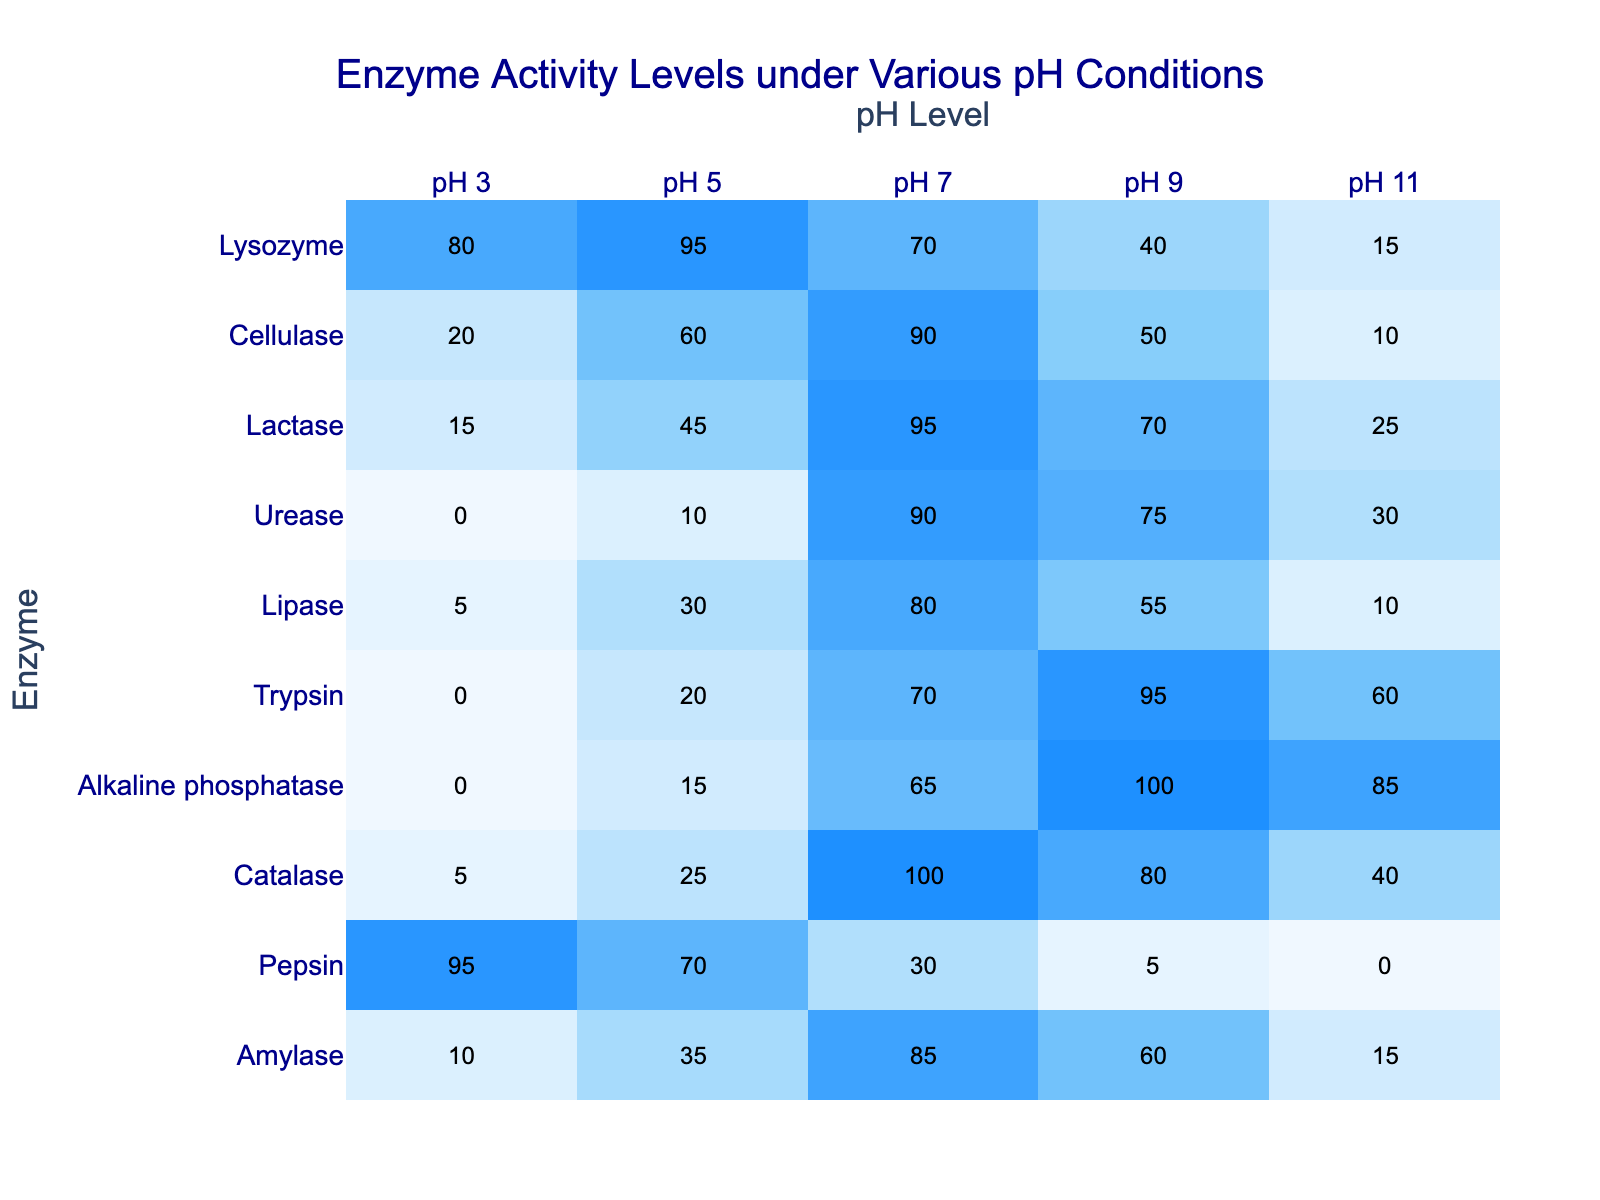What is the enzyme with the highest activity level at pH 7? The activity levels for pH 7 are: Amylase (85), Pepsin (30), Catalase (100), Alkaline phosphatase (65), Trypsin (70), Lipase (80), Urease (90), Lactase (95), Cellulase (90), Lysozyme (70). The highest value is Catalase at 100.
Answer: Catalase At which pH does Urease show the lowest activity? The activity levels for Urease are 0 (pH 3), 10 (pH 5), 90 (pH 7), 75 (pH 9), and 30 (pH 11). The lowest activity level is 0 at pH 3.
Answer: pH 3 What is the average enzyme activity level at pH 9? The activity levels at pH 9 are: 60 (Amylase), 5 (Pepsin), 80 (Catalase), 100 (Alkaline phosphatase), 95 (Trypsin), 55 (Lipase), 75 (Urease), 70 (Lactase), 50 (Cellulase), and 40 (Lysozyme). The sum of these values is 60 + 5 + 80 + 100 + 95 + 55 + 75 + 70 + 50 + 40 = 675. Dividing this by the total number (10) gives an average of 67.5.
Answer: 67.5 Which enzyme exhibited a drop in activity when comparing pH 5 to pH 7? At pH 5 and pH 7, the activity levels for each enzyme are: Amylase (35 to 85), Pepsin (70 to 30), Catalase (25 to 100), Alkaline phosphatase (15 to 65), Trypsin (20 to 70), Lipase (30 to 80), Urease (10 to 90), Lactase (45 to 95), Cellulase (60 to 90), and Lysozyme (95 to 70). Pepsin is the only enzyme that shows a drop in activity from 70 to 30.
Answer: Pepsin What percentage drop in activity does Amylase experience when changing from pH 7 to pH 11? The activity level of Amylase at pH 7 is 85 and at pH 11 is 15. The drop in activity is calculated as: (85 - 15) = 70. The percentage drop is (70 / 85) * 100 = 82.35%.
Answer: 82.35% Is there any enzyme that has zero activity at pH 11? Checking the activity levels at pH 11: Amylase (15), Pepsin (0), Catalase (40), Alkaline phosphatase (85), Trypsin (60), Lipase (10), Urease (30), Lactase (25), Cellulase (10), and Lysozyme (15). Pepsin shows zero activity at pH 11.
Answer: Yes Which enzyme has the highest difference in activity between pH 3 and pH 11? The activity differences for each enzyme are calculated as follows: Amylase (10 - 15 = 5), Pepsin (95 - 0 = 95), Catalase (5 - 40 = 35), Alkaline phosphatase (0 - 85 = 85), Trypsin (0 - 60 = 60), Lipase (5 - 10 = 5), Urease (0 - 30 = 30), Lactase (15 - 25 = 10), Cellulase (20 - 10 = 10), and Lysozyme (80 - 15 = 65). The highest difference is for Pepsin with 95.
Answer: Pepsin What is the total enzyme activity at pH 5? The activity levels at pH 5 are: 35 (Amylase), 70 (Pepsin), 25 (Catalase), 15 (Alkaline phosphatase), 20 (Trypsin), 30 (Lipase), 10 (Urease), 45 (Lactase), 60 (Cellulase), and 95 (Lysozyme). The total sum is 35 + 70 + 25 + 15 + 20 + 30 + 10 + 45 + 60 + 95 = 435.
Answer: 435 How many enzymes have an activity level higher than 90 at pH 7? The activity levels at pH 7 show: Amylase (85), Pepsin (30), Catalase (100), Alkaline phosphatase (65), Trypsin (70), Lipase (80), Urease (90), Lactase (95), Cellulase (90), Lysozyme (70). The only enzymes above 90 are Catalase (100) and Lactase (95), totaling 2 enzymes.
Answer: 2 